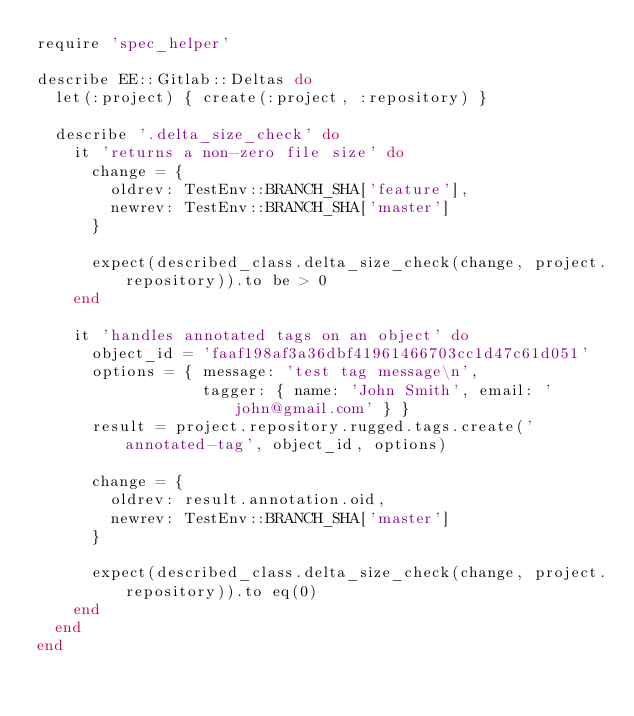<code> <loc_0><loc_0><loc_500><loc_500><_Ruby_>require 'spec_helper'

describe EE::Gitlab::Deltas do
  let(:project) { create(:project, :repository) }

  describe '.delta_size_check' do
    it 'returns a non-zero file size' do
      change = {
        oldrev: TestEnv::BRANCH_SHA['feature'],
        newrev: TestEnv::BRANCH_SHA['master']
      }

      expect(described_class.delta_size_check(change, project.repository)).to be > 0
    end

    it 'handles annotated tags on an object' do
      object_id = 'faaf198af3a36dbf41961466703cc1d47c61d051'
      options = { message: 'test tag message\n',
                  tagger: { name: 'John Smith', email: 'john@gmail.com' } }
      result = project.repository.rugged.tags.create('annotated-tag', object_id, options)

      change = {
        oldrev: result.annotation.oid,
        newrev: TestEnv::BRANCH_SHA['master']
      }

      expect(described_class.delta_size_check(change, project.repository)).to eq(0)
    end
  end
end
</code> 